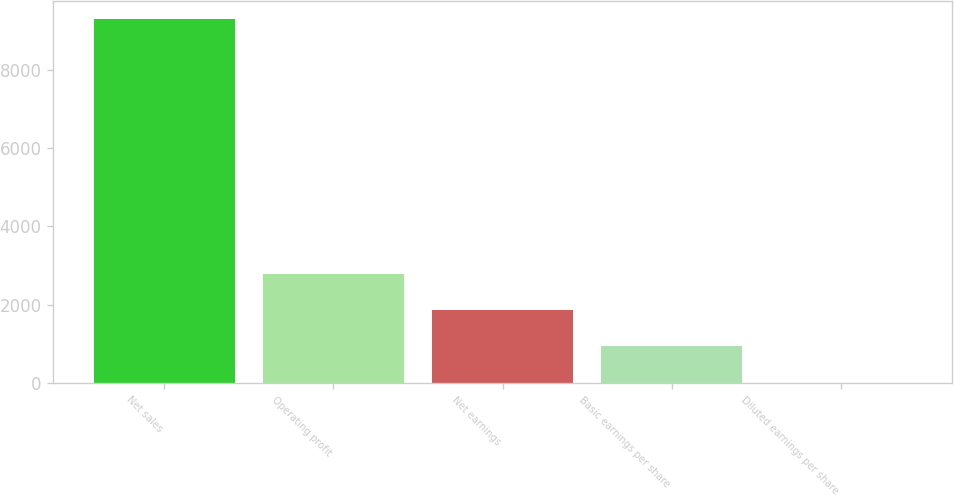Convert chart to OTSL. <chart><loc_0><loc_0><loc_500><loc_500><bar_chart><fcel>Net sales<fcel>Operating profit<fcel>Net earnings<fcel>Basic earnings per share<fcel>Diluted earnings per share<nl><fcel>9295<fcel>2789.22<fcel>1859.82<fcel>930.42<fcel>1.02<nl></chart> 